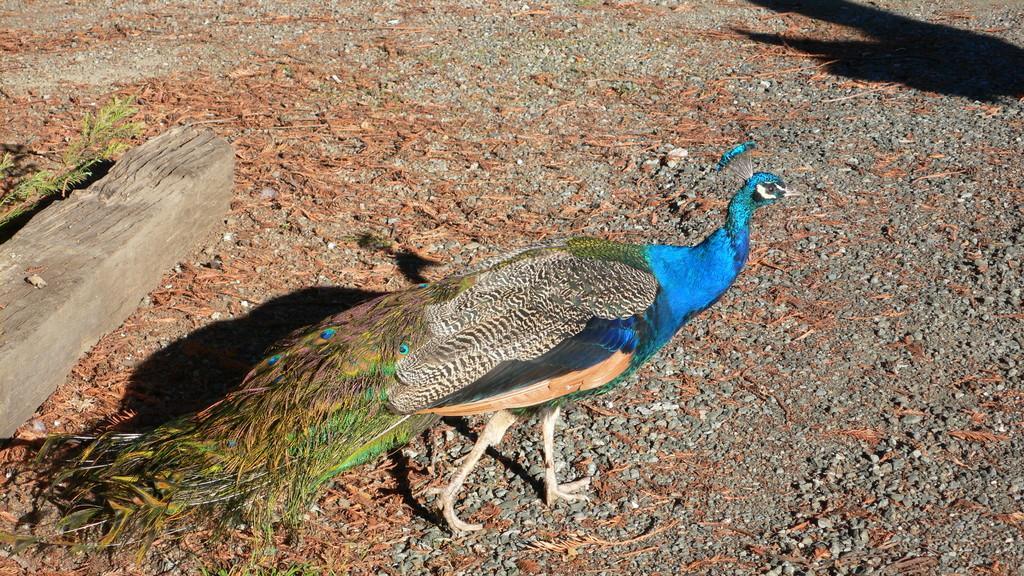Please provide a concise description of this image. In this image I can see a peacock in the front. On the left side of this image I can see a wooden thing and grass. On the top right corner of this image I can see a shadow and I can also see stones on the ground. 